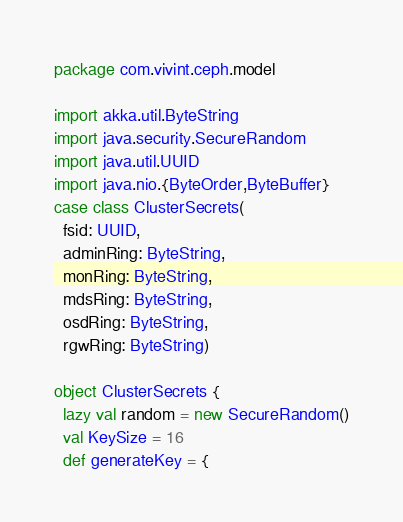<code> <loc_0><loc_0><loc_500><loc_500><_Scala_>package com.vivint.ceph.model

import akka.util.ByteString
import java.security.SecureRandom
import java.util.UUID
import java.nio.{ByteOrder,ByteBuffer}
case class ClusterSecrets(
  fsid: UUID,
  adminRing: ByteString,
  monRing: ByteString,
  mdsRing: ByteString,
  osdRing: ByteString,
  rgwRing: ByteString)

object ClusterSecrets {
  lazy val random = new SecureRandom()
  val KeySize = 16
  def generateKey = {</code> 